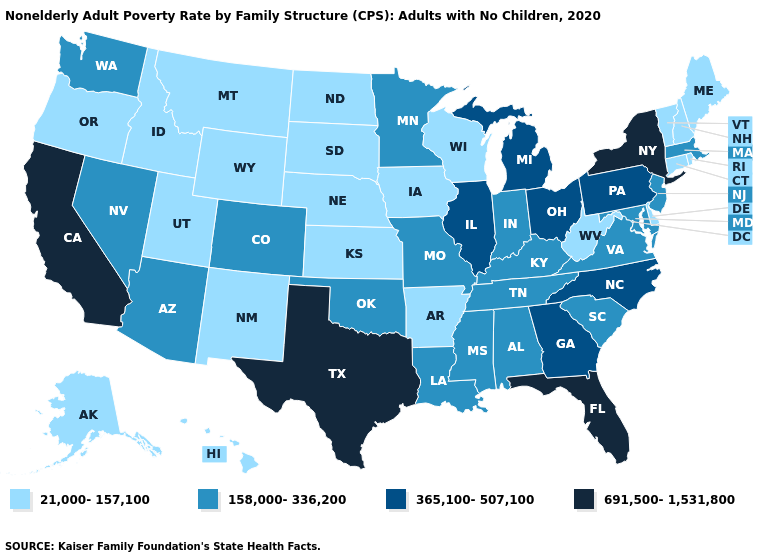Which states hav the highest value in the West?
Give a very brief answer. California. What is the value of Missouri?
Short answer required. 158,000-336,200. Which states hav the highest value in the West?
Answer briefly. California. What is the value of North Carolina?
Short answer required. 365,100-507,100. Does North Dakota have the lowest value in the MidWest?
Quick response, please. Yes. What is the highest value in states that border Vermont?
Write a very short answer. 691,500-1,531,800. Name the states that have a value in the range 365,100-507,100?
Give a very brief answer. Georgia, Illinois, Michigan, North Carolina, Ohio, Pennsylvania. Name the states that have a value in the range 365,100-507,100?
Concise answer only. Georgia, Illinois, Michigan, North Carolina, Ohio, Pennsylvania. What is the value of Alabama?
Be succinct. 158,000-336,200. Among the states that border Maryland , does Delaware have the lowest value?
Concise answer only. Yes. What is the value of Colorado?
Quick response, please. 158,000-336,200. What is the lowest value in the MidWest?
Give a very brief answer. 21,000-157,100. What is the highest value in states that border New Jersey?
Concise answer only. 691,500-1,531,800. Does Massachusetts have the lowest value in the Northeast?
Give a very brief answer. No. What is the highest value in states that border New Mexico?
Write a very short answer. 691,500-1,531,800. 